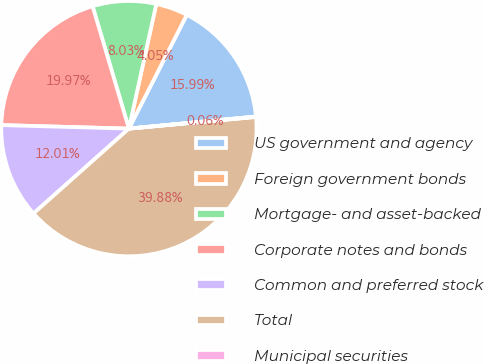Convert chart to OTSL. <chart><loc_0><loc_0><loc_500><loc_500><pie_chart><fcel>US government and agency<fcel>Foreign government bonds<fcel>Mortgage- and asset-backed<fcel>Corporate notes and bonds<fcel>Common and preferred stock<fcel>Total<fcel>Municipal securities<nl><fcel>15.99%<fcel>4.05%<fcel>8.03%<fcel>19.97%<fcel>12.01%<fcel>39.88%<fcel>0.06%<nl></chart> 